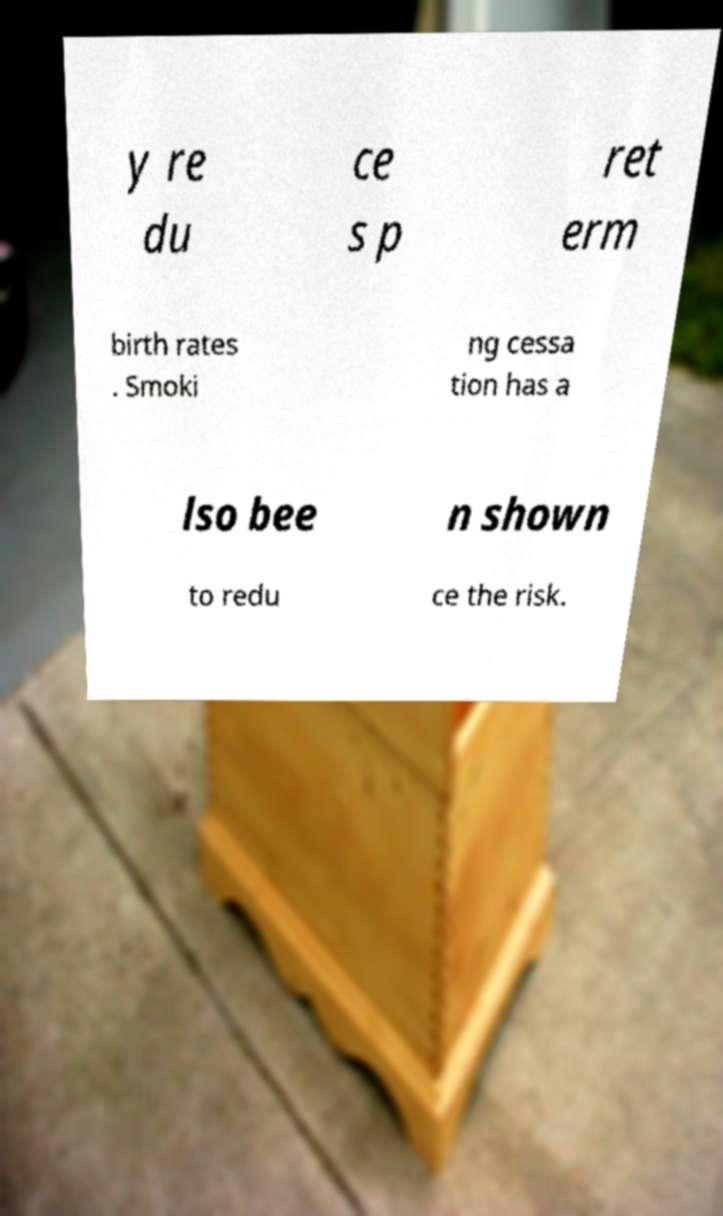What messages or text are displayed in this image? I need them in a readable, typed format. y re du ce s p ret erm birth rates . Smoki ng cessa tion has a lso bee n shown to redu ce the risk. 